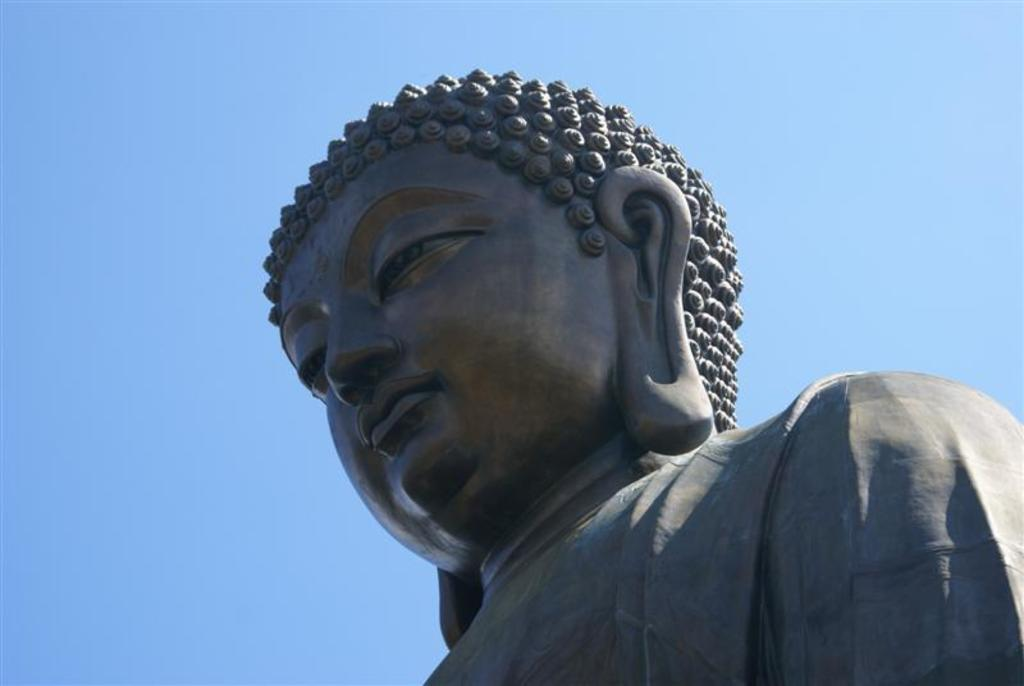What color is the sculpture in the image? The sculpture is black. What color is the sky in the image? The sky is blue. Where is the sister in the image? There is no sister present in the image. What type of paste is being used to create the sculpture in the image? There is no paste being used in the image, as the sculpture is already complete and made of a solid material. 